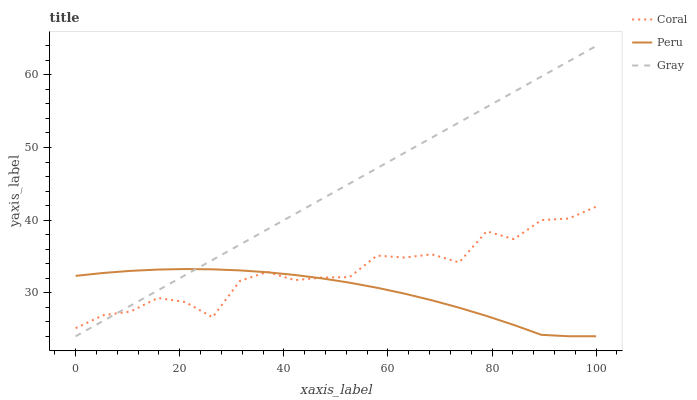Does Peru have the minimum area under the curve?
Answer yes or no. Yes. Does Gray have the maximum area under the curve?
Answer yes or no. Yes. Does Coral have the minimum area under the curve?
Answer yes or no. No. Does Coral have the maximum area under the curve?
Answer yes or no. No. Is Gray the smoothest?
Answer yes or no. Yes. Is Coral the roughest?
Answer yes or no. Yes. Is Peru the smoothest?
Answer yes or no. No. Is Peru the roughest?
Answer yes or no. No. Does Gray have the lowest value?
Answer yes or no. Yes. Does Coral have the lowest value?
Answer yes or no. No. Does Gray have the highest value?
Answer yes or no. Yes. Does Coral have the highest value?
Answer yes or no. No. Does Peru intersect Gray?
Answer yes or no. Yes. Is Peru less than Gray?
Answer yes or no. No. Is Peru greater than Gray?
Answer yes or no. No. 